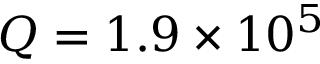Convert formula to latex. <formula><loc_0><loc_0><loc_500><loc_500>Q = 1 . 9 \times 1 0 ^ { 5 }</formula> 